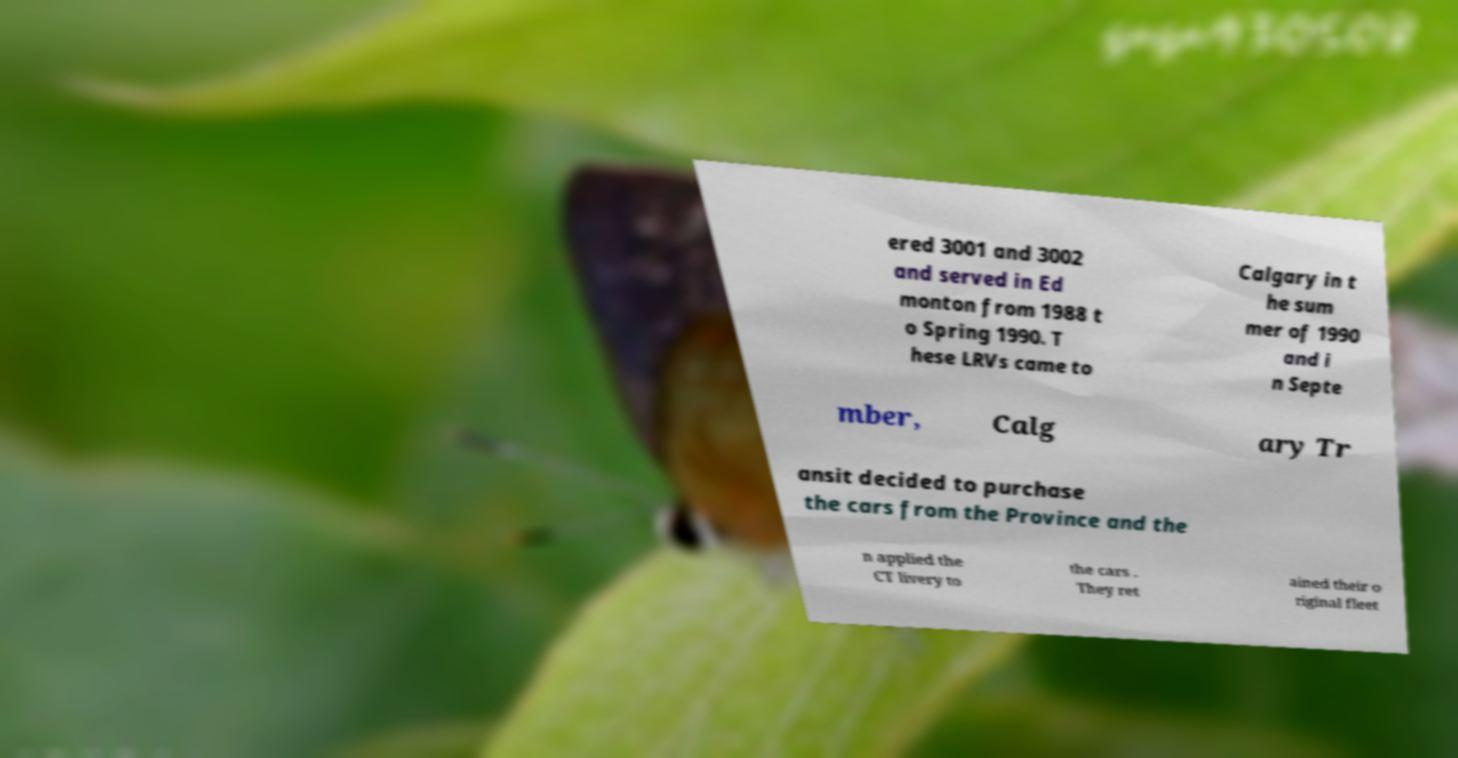Can you accurately transcribe the text from the provided image for me? ered 3001 and 3002 and served in Ed monton from 1988 t o Spring 1990. T hese LRVs came to Calgary in t he sum mer of 1990 and i n Septe mber, Calg ary Tr ansit decided to purchase the cars from the Province and the n applied the CT livery to the cars . They ret ained their o riginal fleet 